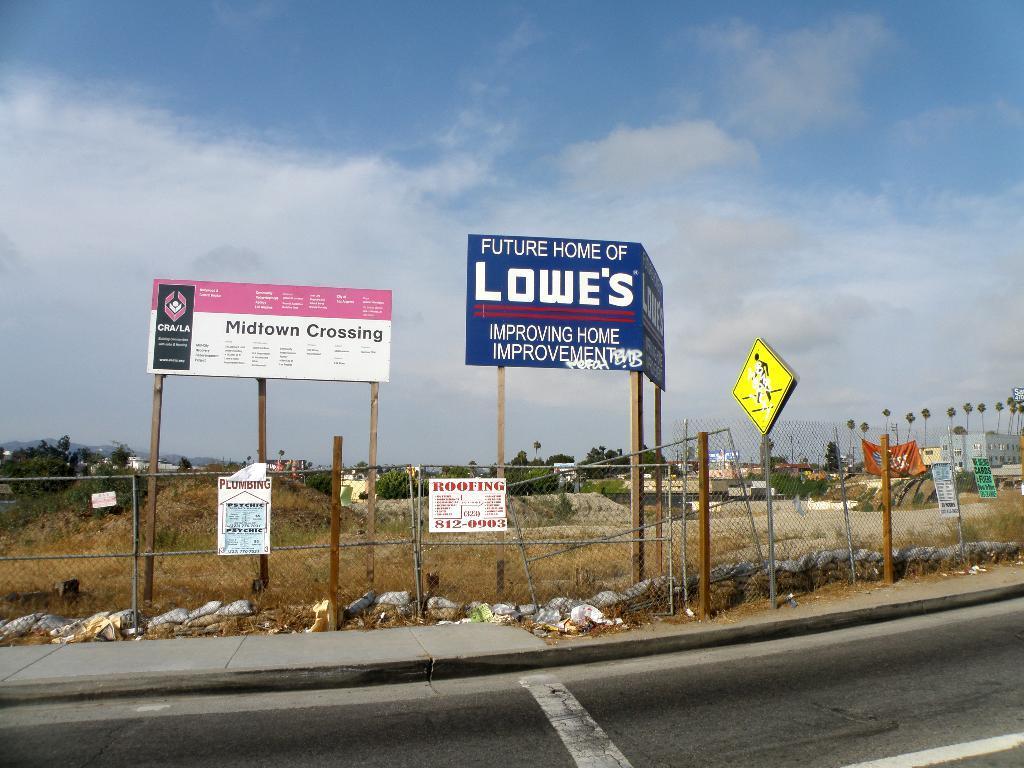Can you describe this image briefly? At the bottom of the picture I can see the road. On the right side of the image I can see trees. In the background, I can see some written text boards. 